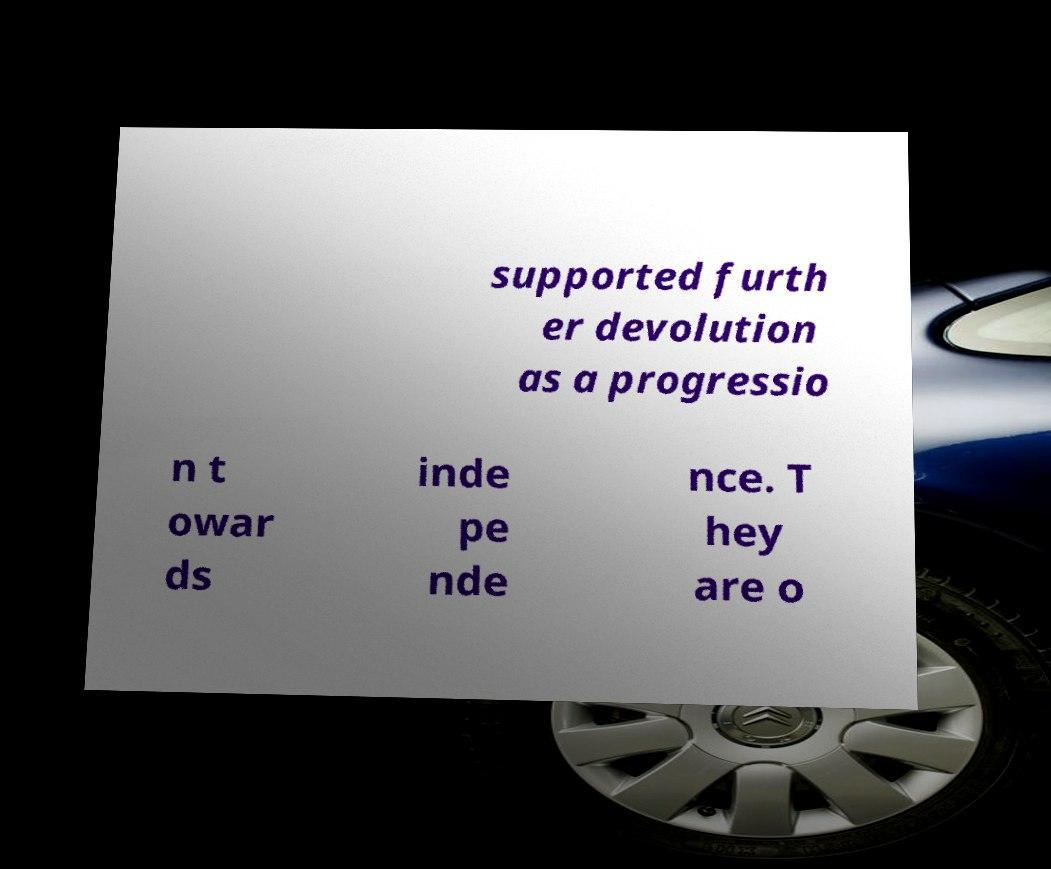Can you accurately transcribe the text from the provided image for me? supported furth er devolution as a progressio n t owar ds inde pe nde nce. T hey are o 